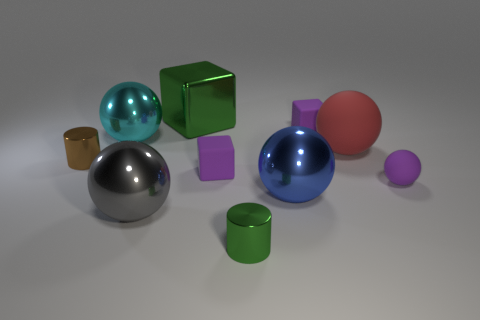Can you describe the lighting direction in the image? The lighting in the image seems to come from above as indicated by the shadows cast mostly downwards and slightly to the left. This overhead lighting creates soft shadows and highlights on the tops of the objects, suggesting a diffuse light source.  How do the shadows contribute to the perception of depth in this image? The shadows in the image contribute to depth perception by creating a sense of space and position among the objects. The difference in shadow length and direction helps to distinguish the relative height and distance of objects from each other and the light source, enhancing the three-dimensional feel of the scene. 